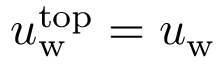<formula> <loc_0><loc_0><loc_500><loc_500>u _ { w } ^ { t o p } = u _ { w }</formula> 